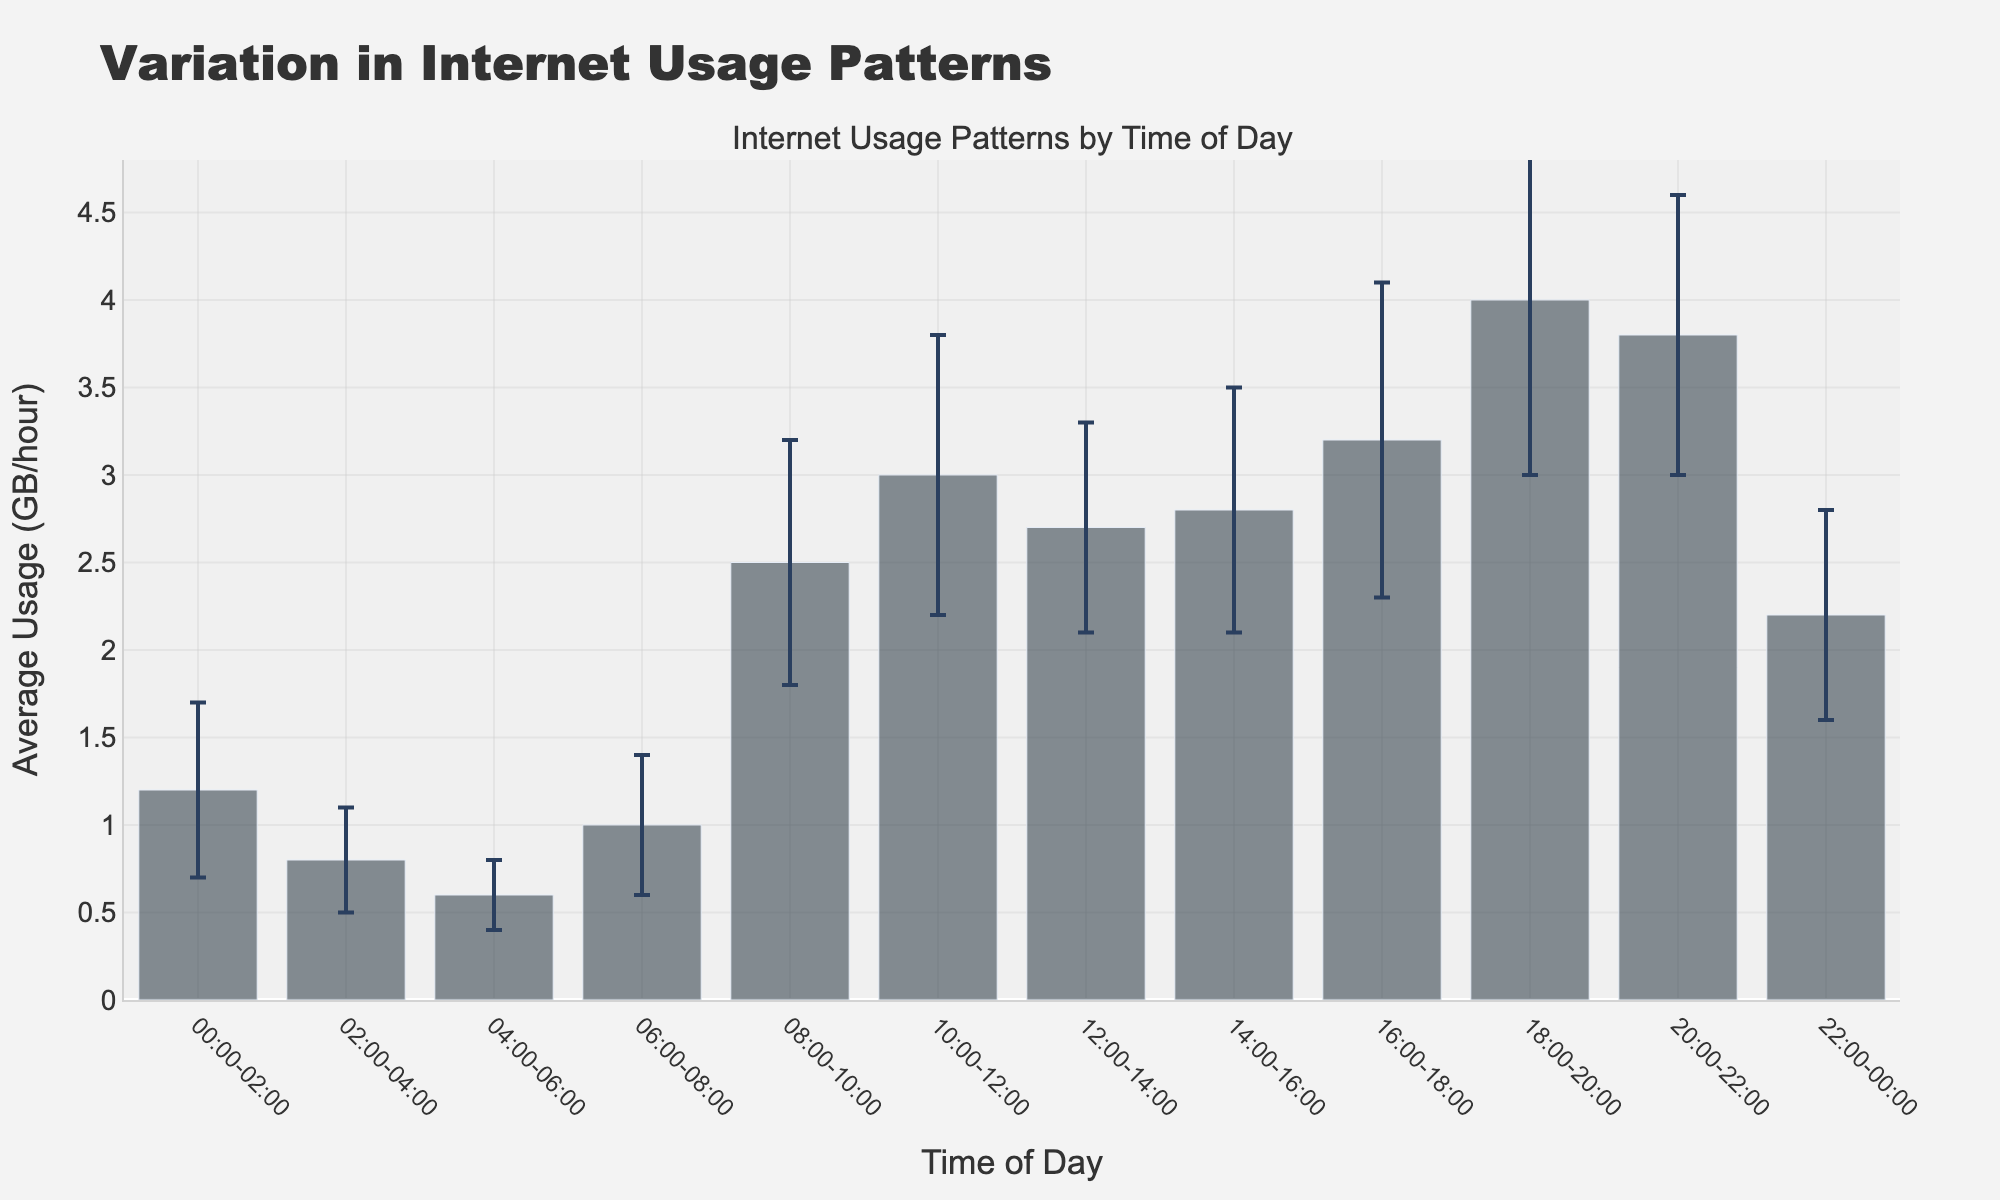what is the title of the figure? The title of the figure is written at the top of the plot, which helps to identify the main subject easily.
Answer: Variation in Internet Usage Patterns what is the range of the y-axis? The y-axis range is set based on the labels on the y-axis, which typically start at 0 and end at a value somewhat higher than the highest data point.
Answer: 0 to 5 At what time of day is the average internet usage the highest? By looking at the height of the bars, we see that the bar for "18:00-20:00" is the highest.
Answer: 18:00-20:00 How much higher is the internet usage at 18:00-20:00 compared to 04:00-06:00? The average usage at 18:00-20:00 is 4.0, and at 04:00-06:00 it is 0.6. Subtracting these values gives the difference.
Answer: 3.4 GB/hour What is the average internet usage for the times 08:00-10:00 and 10:00-12:00? The average usage for 08:00-10:00 is 2.5 and for 10:00-12:00 is 3.0. Adding these together and dividing by 2 gives the average usage.
Answer: 2.75 GB/hour Identify the segment with the smallest standard deviation in usage. The segment with the lowest error bar indicates the smallest standard deviation.
Answer: 04:00-06:00 Compare the standard deviation of internet usage at 14:00-16:00 and 20:00-22:00, and indicate which is larger. The standard deviation for 14:00-16:00 is 0.7, and for 20:00-22:00 it is 0.8.
Answer: 20:00-22:00 During which hours is the internet usage below the average usage of 2.7 at 12:00-14:00? Internet usage is below 2.7 during "00:00-02:00," "02:00-04:00," "04:00-06:00," "06:00-08:00," and "22:00-00:00."
Answer: 00:00-02:00, 02:00-04:00, 04:00-06:00, 06:00-08:00, 22:00-00:00 What is the color of the bars in the chart visualizing average usage? The bars are depicted in a uniform color, as visible in the plot's characteristics.
Answer: Dark gray During which time intervals does the standard deviation exceed 0.7? We need to locate segments with an error bar height over 0.7. These correspond to 18:00-20:00 (1.0), 16:00-18:00 (0.9), and 10:00-12:00 (0.8).
Answer: 10:00-12:00, 16:00-18:00, 18:00-20:00 